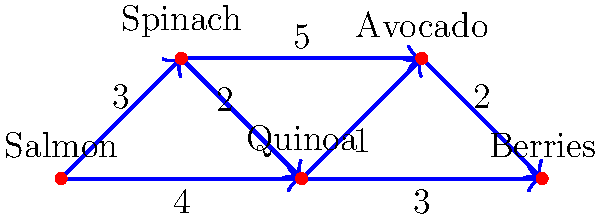As part of your cardiac rehabilitation program, you're designing a heart-healthy meal plan. The graph represents the nutritional compatibility between different ingredients, with edge weights indicating the strength of their synergy. What is the total synergy value of the minimum spanning tree that connects all these heart-healthy ingredients to create a balanced meal plan? To find the minimum spanning tree (MST) of this graph, we can use Kruskal's algorithm:

1. Sort all edges by weight in ascending order:
   (Quinoa - Avocado, 1), (Spinach - Quinoa, 2), (Avocado - Berries, 2), (Salmon - Spinach, 3), (Quinoa - Berries, 3), (Salmon - Quinoa, 4), (Spinach - Avocado, 5)

2. Start with an empty MST and add edges in this order, skipping any that would create a cycle:

   a. (Quinoa - Avocado, 1): Add to MST
   b. (Spinach - Quinoa, 2): Add to MST
   c. (Avocado - Berries, 2): Add to MST
   d. (Salmon - Spinach, 3): Add to MST

3. After adding these 4 edges, all 5 vertices are connected without cycles. This forms our MST.

4. Sum the weights of the edges in the MST:
   $1 + 2 + 2 + 3 = 8$

Therefore, the total synergy value of the minimum spanning tree is 8.
Answer: 8 